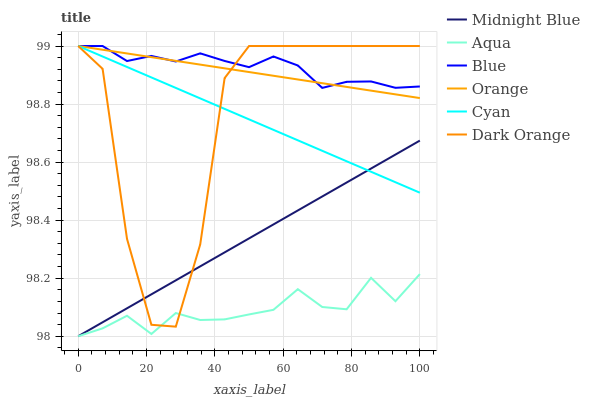Does Aqua have the minimum area under the curve?
Answer yes or no. Yes. Does Blue have the maximum area under the curve?
Answer yes or no. Yes. Does Dark Orange have the minimum area under the curve?
Answer yes or no. No. Does Dark Orange have the maximum area under the curve?
Answer yes or no. No. Is Orange the smoothest?
Answer yes or no. Yes. Is Dark Orange the roughest?
Answer yes or no. Yes. Is Midnight Blue the smoothest?
Answer yes or no. No. Is Midnight Blue the roughest?
Answer yes or no. No. Does Dark Orange have the lowest value?
Answer yes or no. No. Does Cyan have the highest value?
Answer yes or no. Yes. Does Midnight Blue have the highest value?
Answer yes or no. No. Is Midnight Blue less than Orange?
Answer yes or no. Yes. Is Blue greater than Midnight Blue?
Answer yes or no. Yes. Does Cyan intersect Midnight Blue?
Answer yes or no. Yes. Is Cyan less than Midnight Blue?
Answer yes or no. No. Is Cyan greater than Midnight Blue?
Answer yes or no. No. Does Midnight Blue intersect Orange?
Answer yes or no. No. 